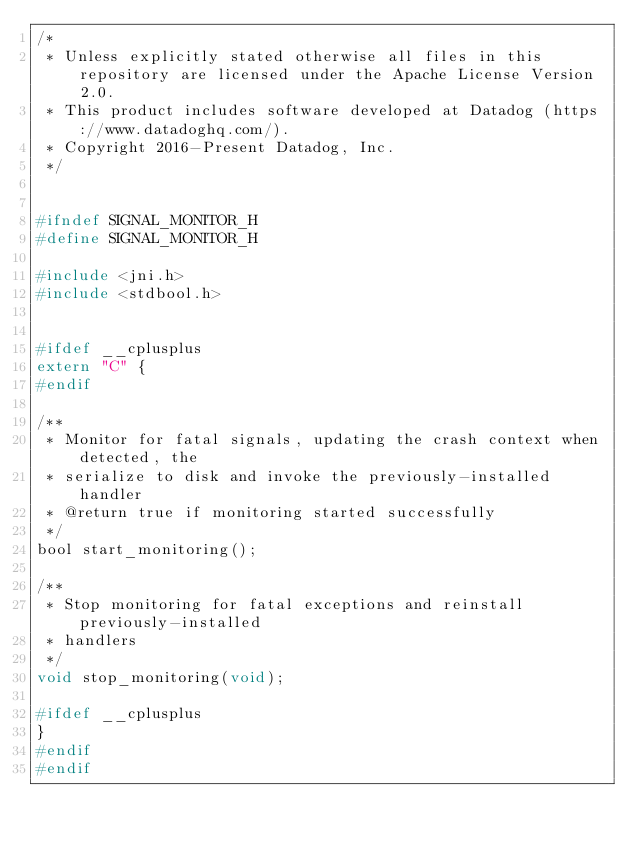Convert code to text. <code><loc_0><loc_0><loc_500><loc_500><_C_>/*
 * Unless explicitly stated otherwise all files in this repository are licensed under the Apache License Version 2.0.
 * This product includes software developed at Datadog (https://www.datadoghq.com/).
 * Copyright 2016-Present Datadog, Inc.
 */


#ifndef SIGNAL_MONITOR_H
#define SIGNAL_MONITOR_H

#include <jni.h>
#include <stdbool.h>


#ifdef __cplusplus
extern "C" {
#endif

/**
 * Monitor for fatal signals, updating the crash context when detected, the
 * serialize to disk and invoke the previously-installed handler
 * @return true if monitoring started successfully
 */
bool start_monitoring();

/**
 * Stop monitoring for fatal exceptions and reinstall previously-installed
 * handlers
 */
void stop_monitoring(void);

#ifdef __cplusplus
}
#endif
#endif</code> 